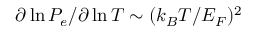<formula> <loc_0><loc_0><loc_500><loc_500>\partial \ln P _ { e } / \partial \ln T \sim ( k _ { B } T / E _ { F } ) ^ { 2 }</formula> 